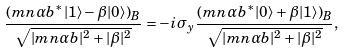Convert formula to latex. <formula><loc_0><loc_0><loc_500><loc_500>\frac { ( m n \alpha b ^ { * } | 1 \rangle - \beta | 0 \rangle ) _ { B } } { \sqrt { | m n \alpha b | ^ { 2 } + | \beta | ^ { 2 } } } = - i \sigma _ { y } \frac { ( m n \alpha b ^ { * } | 0 \rangle + \beta | 1 \rangle ) _ { B } } { \sqrt { | m n \alpha b | ^ { 2 } + | \beta | ^ { 2 } } } ,</formula> 